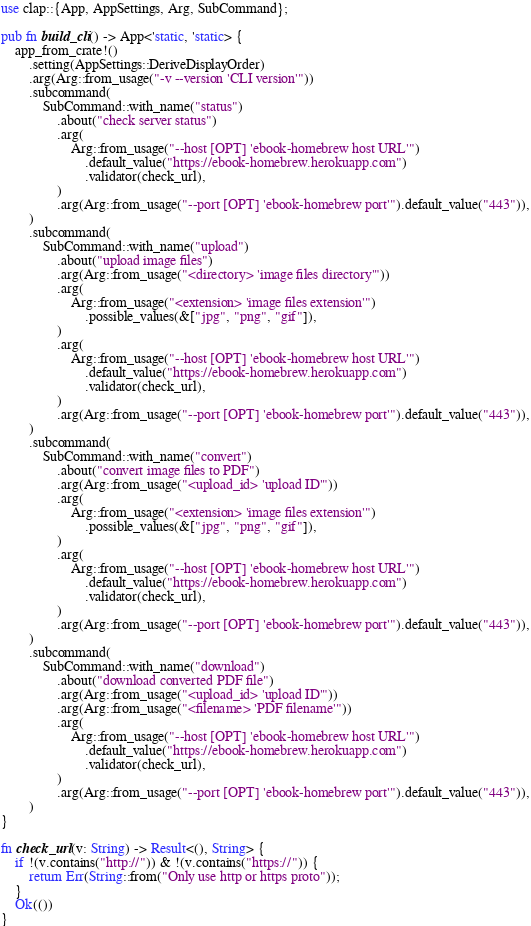Convert code to text. <code><loc_0><loc_0><loc_500><loc_500><_Rust_>use clap::{App, AppSettings, Arg, SubCommand};

pub fn build_cli() -> App<'static, 'static> {
    app_from_crate!()
        .setting(AppSettings::DeriveDisplayOrder)
        .arg(Arg::from_usage("-v --version 'CLI version'"))
        .subcommand(
            SubCommand::with_name("status")
                .about("check server status")
                .arg(
                    Arg::from_usage("--host [OPT] 'ebook-homebrew host URL'")
                        .default_value("https://ebook-homebrew.herokuapp.com")
                        .validator(check_url),
                )
                .arg(Arg::from_usage("--port [OPT] 'ebook-homebrew port'").default_value("443")),
        )
        .subcommand(
            SubCommand::with_name("upload")
                .about("upload image files")
                .arg(Arg::from_usage("<directory> 'image files directory'"))
                .arg(
                    Arg::from_usage("<extension> 'image files extension'")
                        .possible_values(&["jpg", "png", "gif"]),
                )
                .arg(
                    Arg::from_usage("--host [OPT] 'ebook-homebrew host URL'")
                        .default_value("https://ebook-homebrew.herokuapp.com")
                        .validator(check_url),
                )
                .arg(Arg::from_usage("--port [OPT] 'ebook-homebrew port'").default_value("443")),
        )
        .subcommand(
            SubCommand::with_name("convert")
                .about("convert image files to PDF")
                .arg(Arg::from_usage("<upload_id> 'upload ID'"))
                .arg(
                    Arg::from_usage("<extension> 'image files extension'")
                        .possible_values(&["jpg", "png", "gif"]),
                )
                .arg(
                    Arg::from_usage("--host [OPT] 'ebook-homebrew host URL'")
                        .default_value("https://ebook-homebrew.herokuapp.com")
                        .validator(check_url),
                )
                .arg(Arg::from_usage("--port [OPT] 'ebook-homebrew port'").default_value("443")),
        )
        .subcommand(
            SubCommand::with_name("download")
                .about("download converted PDF file")
                .arg(Arg::from_usage("<upload_id> 'upload ID'"))
                .arg(Arg::from_usage("<filename> 'PDF filename'"))
                .arg(
                    Arg::from_usage("--host [OPT] 'ebook-homebrew host URL'")
                        .default_value("https://ebook-homebrew.herokuapp.com")
                        .validator(check_url),
                )
                .arg(Arg::from_usage("--port [OPT] 'ebook-homebrew port'").default_value("443")),
        )
}

fn check_url(v: String) -> Result<(), String> {
    if !(v.contains("http://")) & !(v.contains("https://")) {
        return Err(String::from("Only use http or https proto"));
    }
    Ok(())
}
</code> 